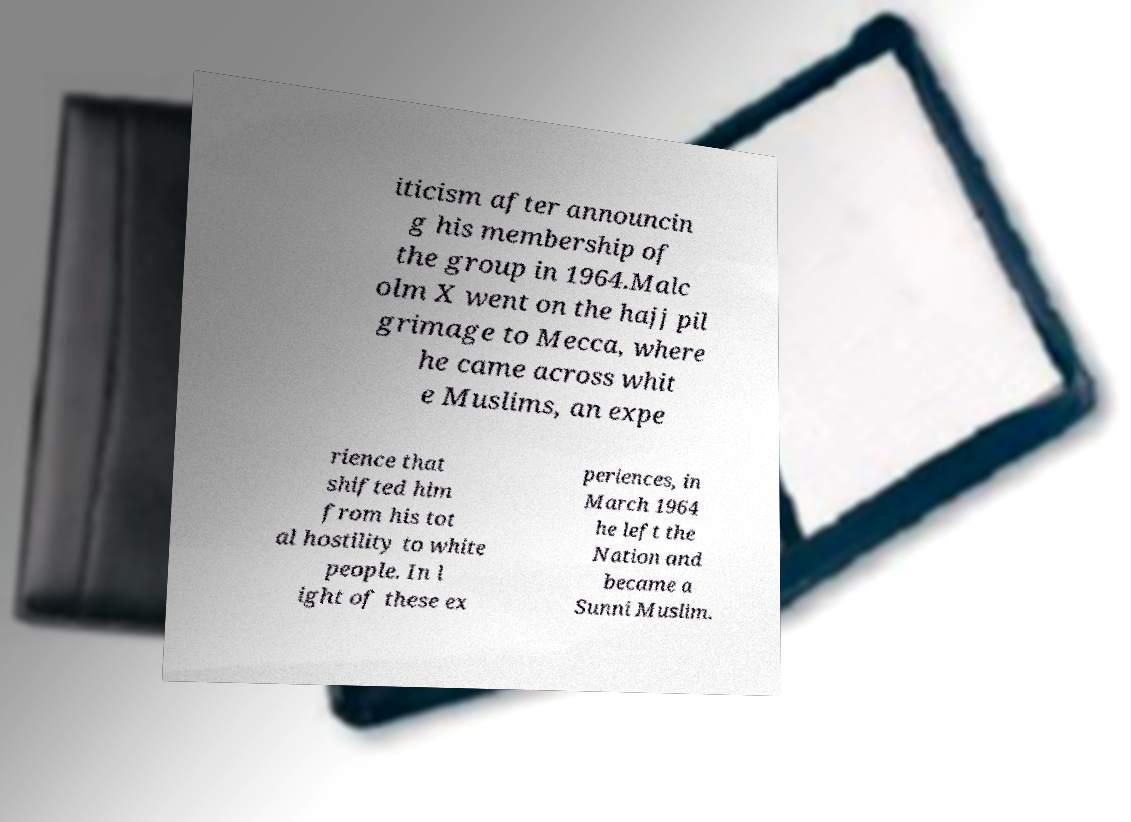Could you assist in decoding the text presented in this image and type it out clearly? iticism after announcin g his membership of the group in 1964.Malc olm X went on the hajj pil grimage to Mecca, where he came across whit e Muslims, an expe rience that shifted him from his tot al hostility to white people. In l ight of these ex periences, in March 1964 he left the Nation and became a Sunni Muslim. 